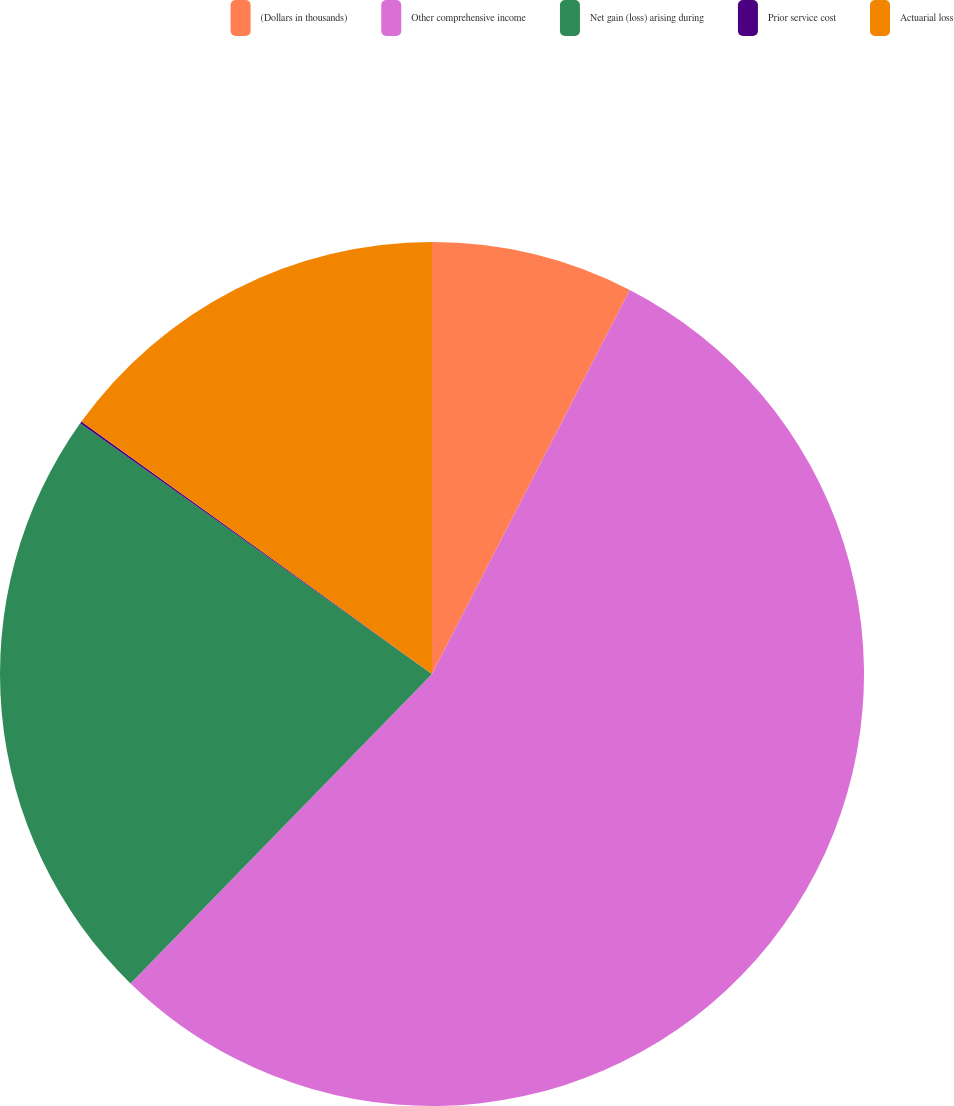<chart> <loc_0><loc_0><loc_500><loc_500><pie_chart><fcel>(Dollars in thousands)<fcel>Other comprehensive income<fcel>Net gain (loss) arising during<fcel>Prior service cost<fcel>Actuarial loss<nl><fcel>7.57%<fcel>54.73%<fcel>22.56%<fcel>0.08%<fcel>15.07%<nl></chart> 